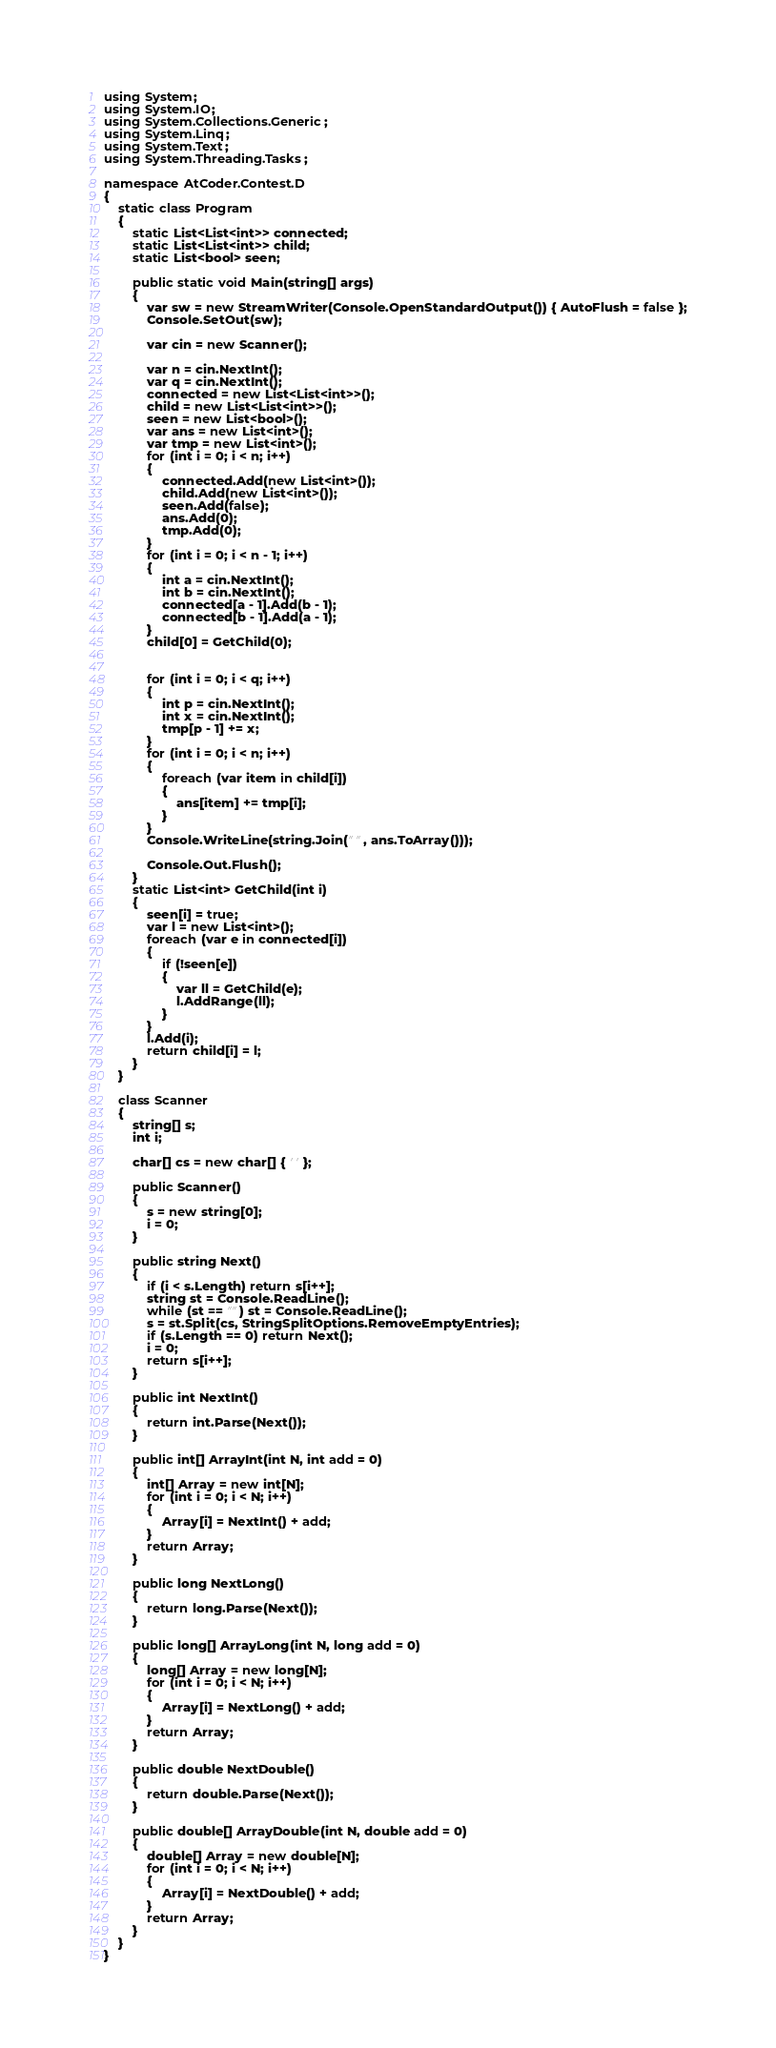<code> <loc_0><loc_0><loc_500><loc_500><_C#_>using System;
using System.IO;
using System.Collections.Generic;
using System.Linq;
using System.Text;
using System.Threading.Tasks;

namespace AtCoder.Contest.D
{
	static class Program
	{
		static List<List<int>> connected;
		static List<List<int>> child;
		static List<bool> seen;

		public static void Main(string[] args)
		{
			var sw = new StreamWriter(Console.OpenStandardOutput()) { AutoFlush = false };
			Console.SetOut(sw);

			var cin = new Scanner();

			var n = cin.NextInt();
			var q = cin.NextInt();
			connected = new List<List<int>>();
			child = new List<List<int>>();
			seen = new List<bool>();
			var ans = new List<int>();
			var tmp = new List<int>();
			for (int i = 0; i < n; i++)
			{
				connected.Add(new List<int>());
				child.Add(new List<int>());
				seen.Add(false);
				ans.Add(0);
				tmp.Add(0);
			}
			for (int i = 0; i < n - 1; i++)
			{
				int a = cin.NextInt();
				int b = cin.NextInt();
				connected[a - 1].Add(b - 1);
				connected[b - 1].Add(a - 1);
			}
			child[0] = GetChild(0);


			for (int i = 0; i < q; i++)
			{
				int p = cin.NextInt();
				int x = cin.NextInt();
				tmp[p - 1] += x;
			}
            for (int i = 0; i < n; i++)
            {
                foreach (var item in child[i])
                {
					ans[item] += tmp[i];
                }
            }
			Console.WriteLine(string.Join(" ", ans.ToArray()));

			Console.Out.Flush();
		}
		static List<int> GetChild(int i)
		{
			seen[i] = true;
			var l = new List<int>();
			foreach (var e in connected[i])
			{
				if (!seen[e])
				{
					var ll = GetChild(e);
					l.AddRange(ll);
				}
			}
			l.Add(i);
			return child[i] = l;
		}
	}

	class Scanner
	{
		string[] s;
		int i;

		char[] cs = new char[] { ' ' };

		public Scanner()
		{
			s = new string[0];
			i = 0;
		}

		public string Next()
		{
			if (i < s.Length) return s[i++];
			string st = Console.ReadLine();
			while (st == "") st = Console.ReadLine();
			s = st.Split(cs, StringSplitOptions.RemoveEmptyEntries);
			if (s.Length == 0) return Next();
			i = 0;
			return s[i++];
		}

		public int NextInt()
		{
			return int.Parse(Next());
		}

		public int[] ArrayInt(int N, int add = 0)
		{
			int[] Array = new int[N];
			for (int i = 0; i < N; i++)
			{
				Array[i] = NextInt() + add;
			}
			return Array;
		}

		public long NextLong()
		{
			return long.Parse(Next());
		}

		public long[] ArrayLong(int N, long add = 0)
		{
			long[] Array = new long[N];
			for (int i = 0; i < N; i++)
			{
				Array[i] = NextLong() + add;
			}
			return Array;
		}

		public double NextDouble()
		{
			return double.Parse(Next());
		}

		public double[] ArrayDouble(int N, double add = 0)
		{
			double[] Array = new double[N];
			for (int i = 0; i < N; i++)
			{
				Array[i] = NextDouble() + add;
			}
			return Array;
		}
	}
}</code> 